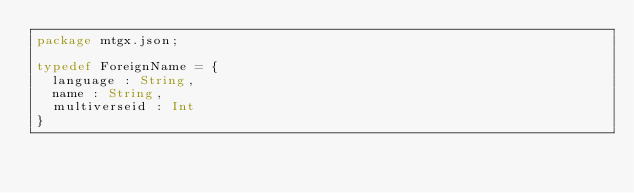Convert code to text. <code><loc_0><loc_0><loc_500><loc_500><_Haxe_>package mtgx.json;

typedef ForeignName = {
  language : String,
  name : String,
  multiverseid : Int
}
</code> 